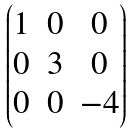Convert formula to latex. <formula><loc_0><loc_0><loc_500><loc_500>\begin{pmatrix} 1 & 0 & 0 \\ 0 & 3 & 0 \\ 0 & 0 & - 4 \\ \end{pmatrix}</formula> 